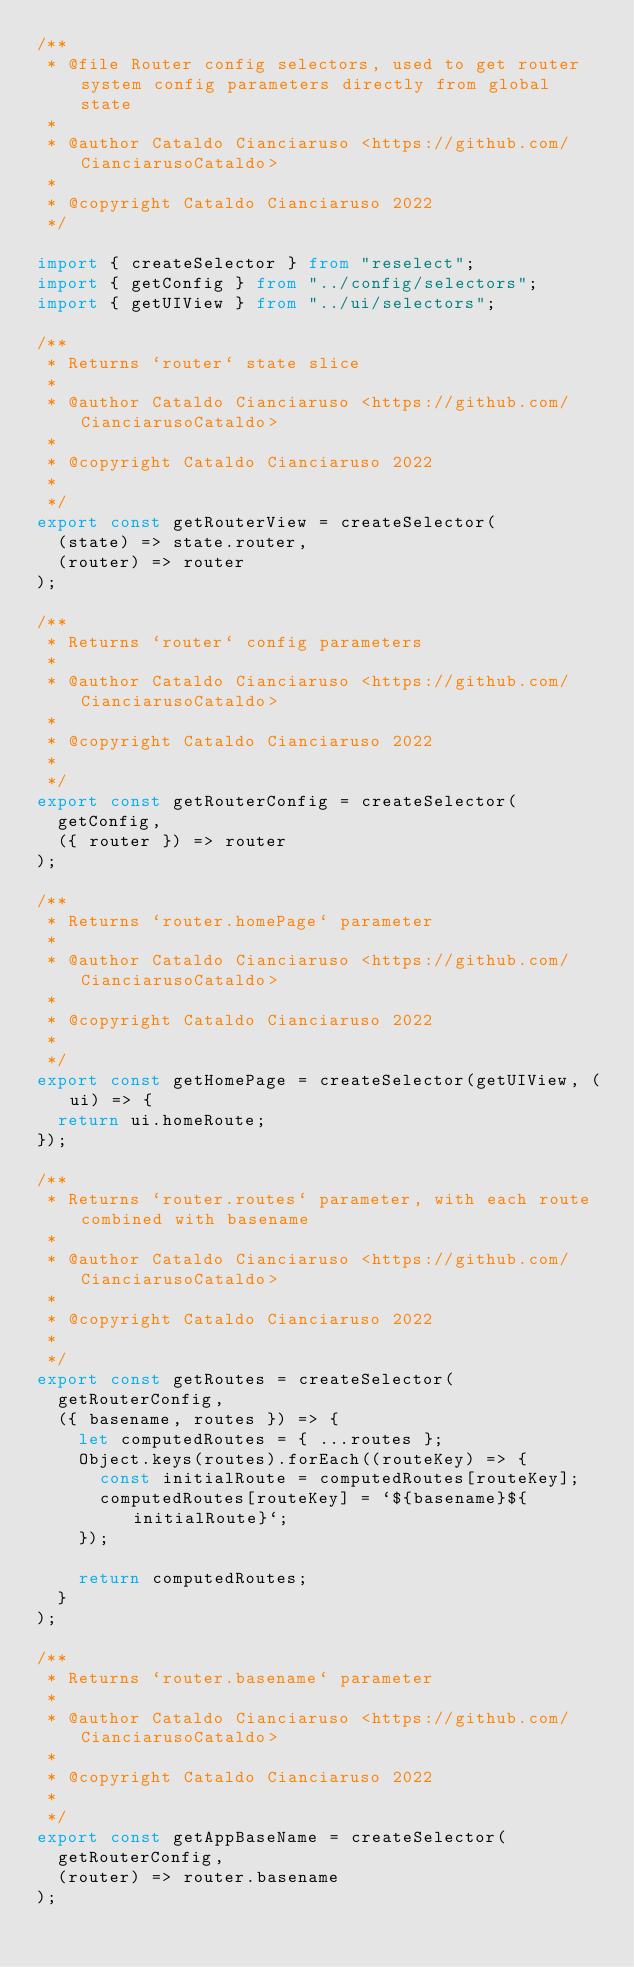Convert code to text. <code><loc_0><loc_0><loc_500><loc_500><_TypeScript_>/**
 * @file Router config selectors, used to get router system config parameters directly from global state
 *
 * @author Cataldo Cianciaruso <https://github.com/CianciarusoCataldo>
 *
 * @copyright Cataldo Cianciaruso 2022
 */

import { createSelector } from "reselect";
import { getConfig } from "../config/selectors";
import { getUIView } from "../ui/selectors";

/**
 * Returns `router` state slice
 *
 * @author Cataldo Cianciaruso <https://github.com/CianciarusoCataldo>
 *
 * @copyright Cataldo Cianciaruso 2022
 *
 */
export const getRouterView = createSelector(
  (state) => state.router,
  (router) => router
);

/**
 * Returns `router` config parameters
 *
 * @author Cataldo Cianciaruso <https://github.com/CianciarusoCataldo>
 *
 * @copyright Cataldo Cianciaruso 2022
 *
 */
export const getRouterConfig = createSelector(
  getConfig,
  ({ router }) => router
);

/**
 * Returns `router.homePage` parameter
 *
 * @author Cataldo Cianciaruso <https://github.com/CianciarusoCataldo>
 *
 * @copyright Cataldo Cianciaruso 2022
 *
 */
export const getHomePage = createSelector(getUIView, (ui) => {
  return ui.homeRoute;
});

/**
 * Returns `router.routes` parameter, with each route combined with basename
 *
 * @author Cataldo Cianciaruso <https://github.com/CianciarusoCataldo>
 *
 * @copyright Cataldo Cianciaruso 2022
 *
 */
export const getRoutes = createSelector(
  getRouterConfig,
  ({ basename, routes }) => {
    let computedRoutes = { ...routes };
    Object.keys(routes).forEach((routeKey) => {
      const initialRoute = computedRoutes[routeKey];
      computedRoutes[routeKey] = `${basename}${initialRoute}`;
    });

    return computedRoutes;
  }
);

/**
 * Returns `router.basename` parameter
 *
 * @author Cataldo Cianciaruso <https://github.com/CianciarusoCataldo>
 *
 * @copyright Cataldo Cianciaruso 2022
 *
 */
export const getAppBaseName = createSelector(
  getRouterConfig,
  (router) => router.basename
);
</code> 